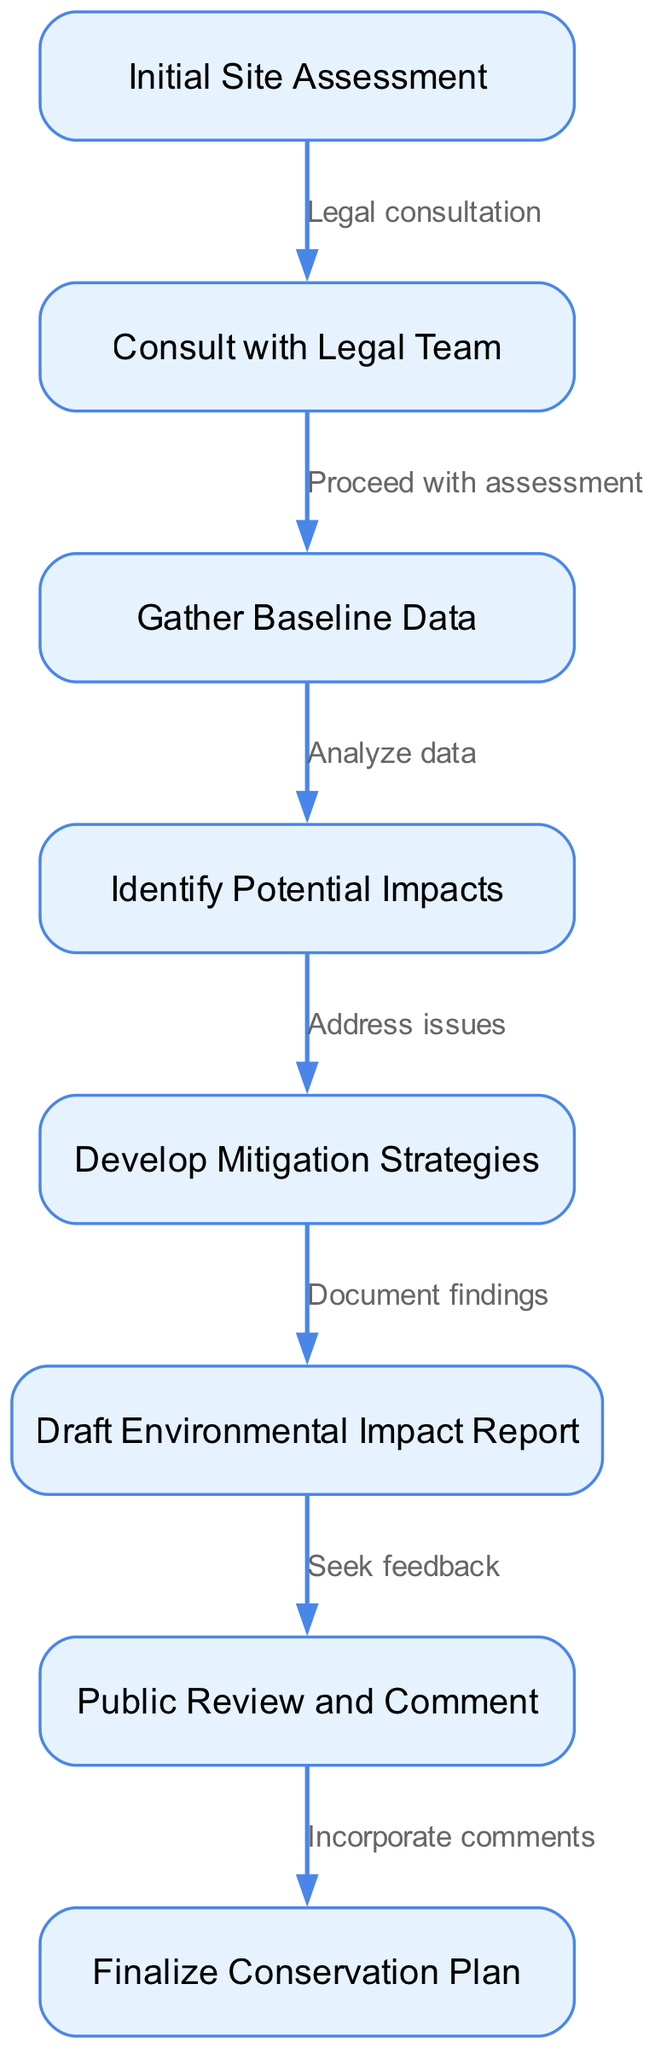What is the first step in the environmental impact assessment workflow? The first step is labeled as "Initial Site Assessment" in the diagram, which indicates it is the starting point of the workflow.
Answer: Initial Site Assessment How many nodes are present in the diagram? By counting each unique process or stage represented in the diagram, we find there are a total of eight nodes.
Answer: 8 Which node leads to "Gather Baseline Data"? Following the edges in the diagram, "Gather Baseline Data" is preceded by the node "Consult with Legal Team," which indicates the sequence of actions.
Answer: Consult with Legal Team What is the relationship between "Draft Environmental Impact Report" and "Public Review and Comment"? The diagram shows a direct link between "Draft Environmental Impact Report" and "Public Review and Comment," with the edge indicating the progression from drafting to seeking feedback.
Answer: Seek feedback What is the last step in the workflow? The last step of the flow chart, as indicated by its position and connection, is "Finalize Conservation Plan," which concludes the assessment process.
Answer: Finalize Conservation Plan How does the process transition from "Identify Potential Impacts" to "Develop Mitigation Strategies"? The transition between "Identify Potential Impacts" and "Develop Mitigation Strategies" is described by the edge labeled "Address issues," indicating a necessary response to issues identified before moving forward.
Answer: Address issues Which node is directly after "Public Review and Comment"? By examining the flow of the diagram, the node that follows "Public Review and Comment" is "Finalize Conservation Plan," indicating the next step after feedback is incorporated.
Answer: Finalize Conservation Plan What is the purpose of the "Gather Baseline Data" node? The purpose of this node is to collect and analyze information about the environment before identifying potential impacts, as indicated by the connection to the next step.
Answer: Analyze data How many edges connect the nodes in the diagram? By counting the lines connecting nodes, which show the flow of the process, we find there are a total of seven edges present in the diagram.
Answer: 7 